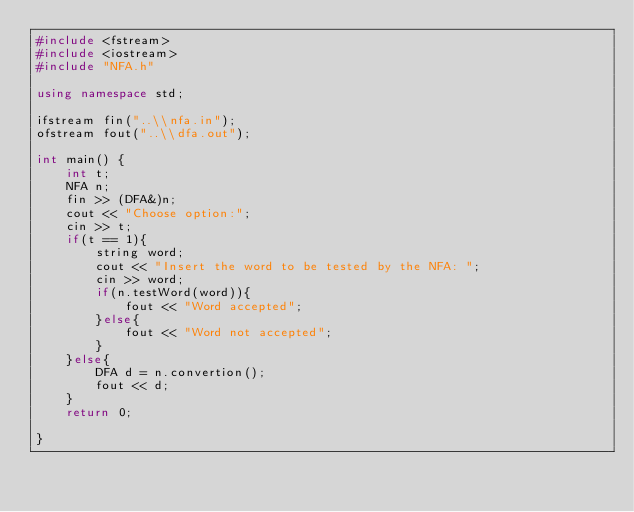Convert code to text. <code><loc_0><loc_0><loc_500><loc_500><_C++_>#include <fstream>
#include <iostream>
#include "NFA.h"

using namespace std;

ifstream fin("..\\nfa.in");
ofstream fout("..\\dfa.out");

int main() {
    int t;
    NFA n;
    fin >> (DFA&)n;
    cout << "Choose option:";
    cin >> t;
    if(t == 1){
        string word;
        cout << "Insert the word to be tested by the NFA: ";
        cin >> word;
        if(n.testWord(word)){
            fout << "Word accepted";
        }else{
            fout << "Word not accepted";
        }
    }else{
        DFA d = n.convertion();
        fout << d;
    }
    return 0;

}</code> 